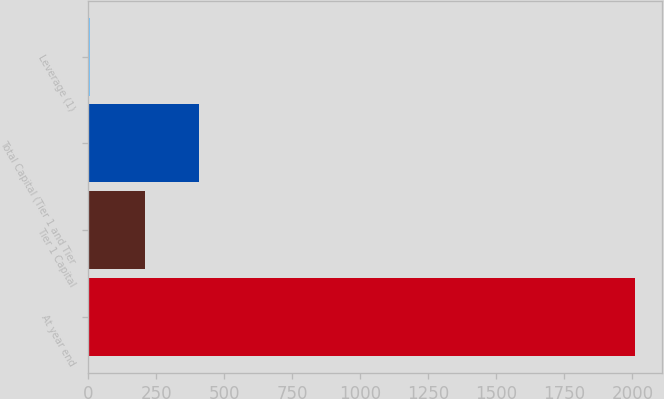<chart> <loc_0><loc_0><loc_500><loc_500><bar_chart><fcel>At year end<fcel>Tier 1 Capital<fcel>Total Capital (Tier 1 and Tier<fcel>Leverage (1)<nl><fcel>2008<fcel>206.27<fcel>406.46<fcel>6.08<nl></chart> 